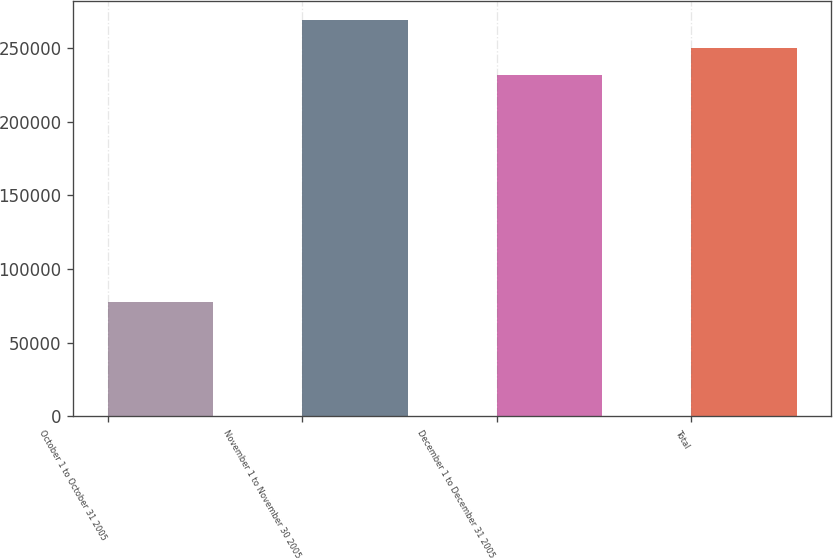Convert chart to OTSL. <chart><loc_0><loc_0><loc_500><loc_500><bar_chart><fcel>October 1 to October 31 2005<fcel>November 1 to November 30 2005<fcel>December 1 to December 31 2005<fcel>Total<nl><fcel>77585<fcel>268595<fcel>231619<fcel>250107<nl></chart> 